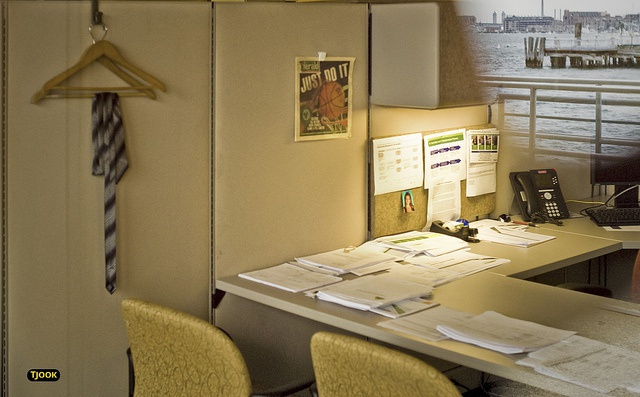Describe the objects in this image and their specific colors. I can see chair in maroon and olive tones, chair in maroon and olive tones, tie in maroon, black, and gray tones, book in maroon, tan, and lightgray tones, and keyboard in black and maroon tones in this image. 